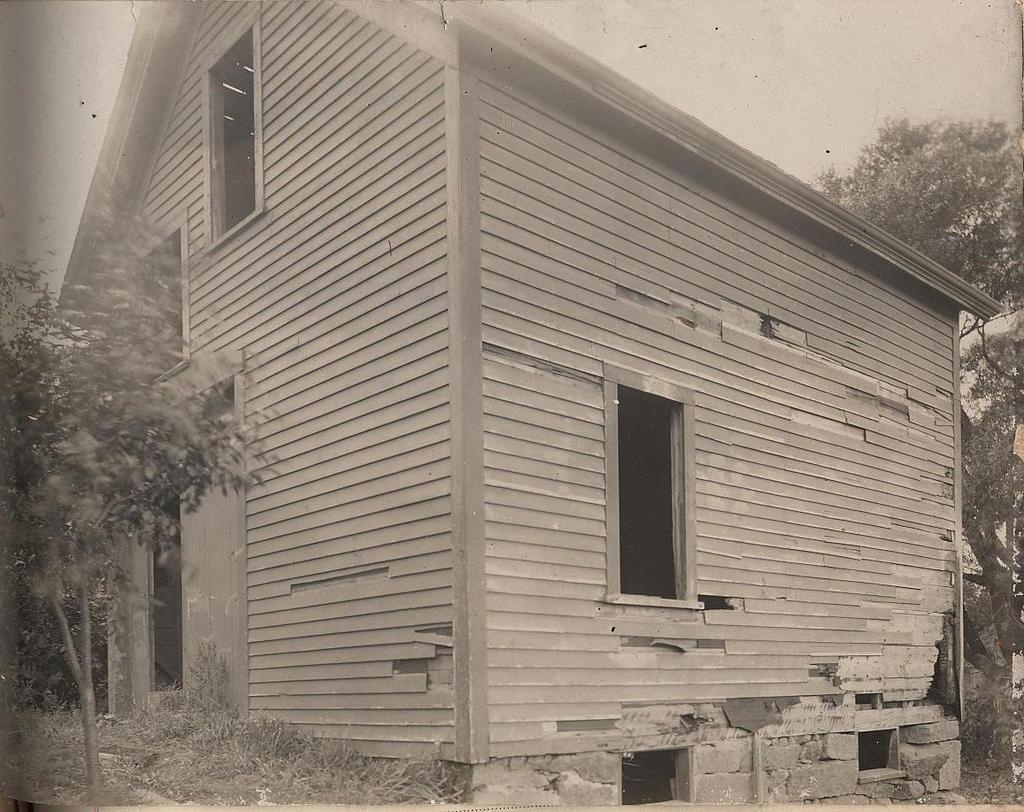What type of structure is visible in the image? There is a house in the image. What can be seen on the left side of the image? There are plants and trees on the grassland on the left side of the image. What is present on the right side of the image? There is a tree on the right side of the image. What is visible at the top of the image? The sky is visible at the top of the image. What type of reaction can be seen happening between the plants and the screw in the image? There is no screw present in the image, and therefore no reaction can be observed between the plants and a screw. 